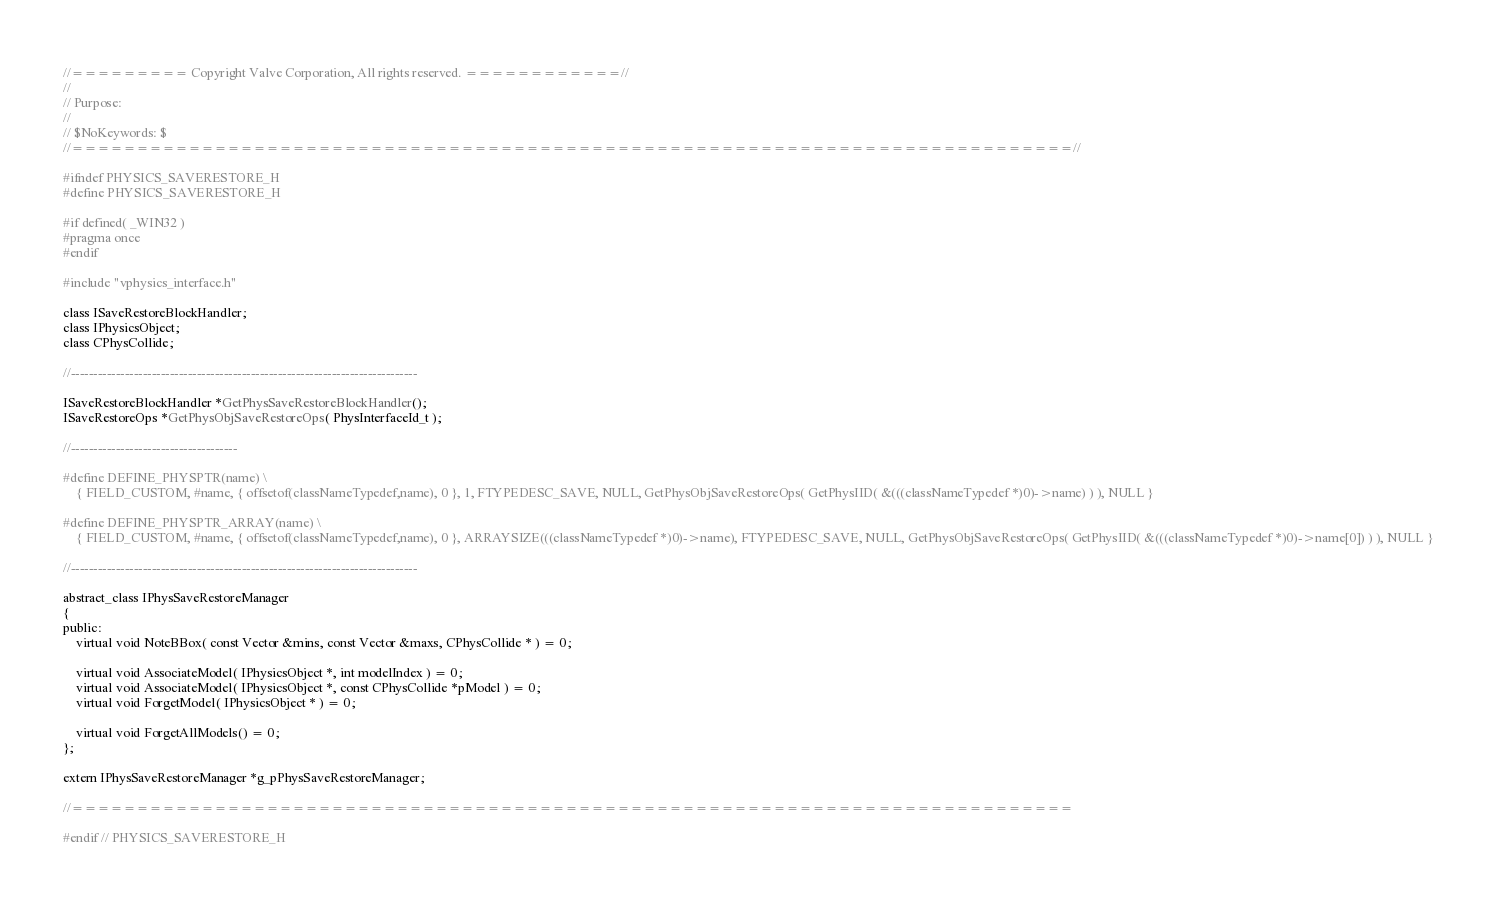<code> <loc_0><loc_0><loc_500><loc_500><_C_>//========= Copyright Valve Corporation, All rights reserved. ============//
//
// Purpose:
//
// $NoKeywords: $
//=============================================================================//

#ifndef PHYSICS_SAVERESTORE_H
#define PHYSICS_SAVERESTORE_H

#if defined( _WIN32 )
#pragma once
#endif

#include "vphysics_interface.h"

class ISaveRestoreBlockHandler;
class IPhysicsObject;
class CPhysCollide;

//-----------------------------------------------------------------------------

ISaveRestoreBlockHandler *GetPhysSaveRestoreBlockHandler();
ISaveRestoreOps *GetPhysObjSaveRestoreOps( PhysInterfaceId_t );

//-------------------------------------

#define DEFINE_PHYSPTR(name) \
	{ FIELD_CUSTOM, #name, { offsetof(classNameTypedef,name), 0 }, 1, FTYPEDESC_SAVE, NULL, GetPhysObjSaveRestoreOps( GetPhysIID( &(((classNameTypedef *)0)->name) ) ), NULL }

#define DEFINE_PHYSPTR_ARRAY(name) \
	{ FIELD_CUSTOM, #name, { offsetof(classNameTypedef,name), 0 }, ARRAYSIZE(((classNameTypedef *)0)->name), FTYPEDESC_SAVE, NULL, GetPhysObjSaveRestoreOps( GetPhysIID( &(((classNameTypedef *)0)->name[0]) ) ), NULL }

//-----------------------------------------------------------------------------

abstract_class IPhysSaveRestoreManager
{
public:
	virtual void NoteBBox( const Vector &mins, const Vector &maxs, CPhysCollide * ) = 0;

	virtual void AssociateModel( IPhysicsObject *, int modelIndex ) = 0;
	virtual void AssociateModel( IPhysicsObject *, const CPhysCollide *pModel ) = 0;
	virtual void ForgetModel( IPhysicsObject * ) = 0;

	virtual void ForgetAllModels() = 0;
};

extern IPhysSaveRestoreManager *g_pPhysSaveRestoreManager;

//=============================================================================

#endif // PHYSICS_SAVERESTORE_H
</code> 